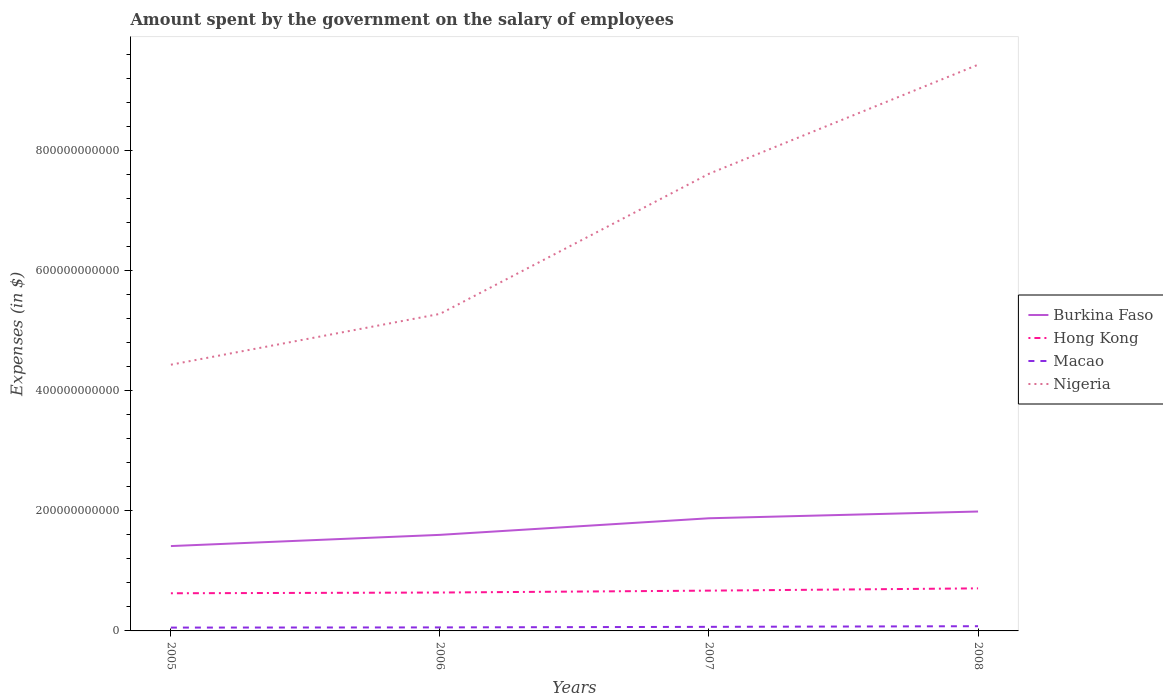How many different coloured lines are there?
Offer a very short reply. 4. Is the number of lines equal to the number of legend labels?
Your response must be concise. Yes. Across all years, what is the maximum amount spent on the salary of employees by the government in Hong Kong?
Your answer should be very brief. 6.27e+1. What is the total amount spent on the salary of employees by the government in Burkina Faso in the graph?
Make the answer very short. -3.89e+1. What is the difference between the highest and the second highest amount spent on the salary of employees by the government in Macao?
Your answer should be very brief. 2.30e+09. Is the amount spent on the salary of employees by the government in Hong Kong strictly greater than the amount spent on the salary of employees by the government in Nigeria over the years?
Provide a succinct answer. Yes. What is the difference between two consecutive major ticks on the Y-axis?
Offer a very short reply. 2.00e+11. Does the graph contain any zero values?
Offer a terse response. No. What is the title of the graph?
Keep it short and to the point. Amount spent by the government on the salary of employees. Does "Guam" appear as one of the legend labels in the graph?
Give a very brief answer. No. What is the label or title of the Y-axis?
Give a very brief answer. Expenses (in $). What is the Expenses (in $) of Burkina Faso in 2005?
Give a very brief answer. 1.41e+11. What is the Expenses (in $) in Hong Kong in 2005?
Ensure brevity in your answer.  6.27e+1. What is the Expenses (in $) in Macao in 2005?
Give a very brief answer. 5.54e+09. What is the Expenses (in $) of Nigeria in 2005?
Offer a terse response. 4.43e+11. What is the Expenses (in $) in Burkina Faso in 2006?
Offer a very short reply. 1.60e+11. What is the Expenses (in $) in Hong Kong in 2006?
Provide a short and direct response. 6.39e+1. What is the Expenses (in $) in Macao in 2006?
Your answer should be compact. 5.86e+09. What is the Expenses (in $) in Nigeria in 2006?
Provide a short and direct response. 5.28e+11. What is the Expenses (in $) in Burkina Faso in 2007?
Give a very brief answer. 1.88e+11. What is the Expenses (in $) in Hong Kong in 2007?
Offer a terse response. 6.71e+1. What is the Expenses (in $) of Macao in 2007?
Give a very brief answer. 6.79e+09. What is the Expenses (in $) in Nigeria in 2007?
Provide a succinct answer. 7.61e+11. What is the Expenses (in $) of Burkina Faso in 2008?
Give a very brief answer. 1.99e+11. What is the Expenses (in $) in Hong Kong in 2008?
Ensure brevity in your answer.  7.09e+1. What is the Expenses (in $) in Macao in 2008?
Your answer should be compact. 7.85e+09. What is the Expenses (in $) in Nigeria in 2008?
Provide a short and direct response. 9.43e+11. Across all years, what is the maximum Expenses (in $) of Burkina Faso?
Offer a terse response. 1.99e+11. Across all years, what is the maximum Expenses (in $) of Hong Kong?
Ensure brevity in your answer.  7.09e+1. Across all years, what is the maximum Expenses (in $) of Macao?
Provide a succinct answer. 7.85e+09. Across all years, what is the maximum Expenses (in $) in Nigeria?
Give a very brief answer. 9.43e+11. Across all years, what is the minimum Expenses (in $) of Burkina Faso?
Ensure brevity in your answer.  1.41e+11. Across all years, what is the minimum Expenses (in $) of Hong Kong?
Provide a short and direct response. 6.27e+1. Across all years, what is the minimum Expenses (in $) of Macao?
Give a very brief answer. 5.54e+09. Across all years, what is the minimum Expenses (in $) in Nigeria?
Offer a very short reply. 4.43e+11. What is the total Expenses (in $) of Burkina Faso in the graph?
Offer a very short reply. 6.88e+11. What is the total Expenses (in $) in Hong Kong in the graph?
Give a very brief answer. 2.65e+11. What is the total Expenses (in $) in Macao in the graph?
Provide a short and direct response. 2.60e+1. What is the total Expenses (in $) in Nigeria in the graph?
Offer a terse response. 2.68e+12. What is the difference between the Expenses (in $) of Burkina Faso in 2005 and that in 2006?
Your answer should be very brief. -1.87e+1. What is the difference between the Expenses (in $) in Hong Kong in 2005 and that in 2006?
Provide a succinct answer. -1.22e+09. What is the difference between the Expenses (in $) of Macao in 2005 and that in 2006?
Your answer should be compact. -3.16e+08. What is the difference between the Expenses (in $) in Nigeria in 2005 and that in 2006?
Provide a succinct answer. -8.46e+1. What is the difference between the Expenses (in $) in Burkina Faso in 2005 and that in 2007?
Your response must be concise. -4.63e+1. What is the difference between the Expenses (in $) of Hong Kong in 2005 and that in 2007?
Make the answer very short. -4.39e+09. What is the difference between the Expenses (in $) of Macao in 2005 and that in 2007?
Make the answer very short. -1.24e+09. What is the difference between the Expenses (in $) in Nigeria in 2005 and that in 2007?
Make the answer very short. -3.18e+11. What is the difference between the Expenses (in $) of Burkina Faso in 2005 and that in 2008?
Your answer should be compact. -5.75e+1. What is the difference between the Expenses (in $) of Hong Kong in 2005 and that in 2008?
Ensure brevity in your answer.  -8.16e+09. What is the difference between the Expenses (in $) of Macao in 2005 and that in 2008?
Ensure brevity in your answer.  -2.30e+09. What is the difference between the Expenses (in $) in Nigeria in 2005 and that in 2008?
Offer a terse response. -5.00e+11. What is the difference between the Expenses (in $) of Burkina Faso in 2006 and that in 2007?
Keep it short and to the point. -2.76e+1. What is the difference between the Expenses (in $) of Hong Kong in 2006 and that in 2007?
Your answer should be very brief. -3.17e+09. What is the difference between the Expenses (in $) in Macao in 2006 and that in 2007?
Give a very brief answer. -9.25e+08. What is the difference between the Expenses (in $) in Nigeria in 2006 and that in 2007?
Offer a very short reply. -2.33e+11. What is the difference between the Expenses (in $) of Burkina Faso in 2006 and that in 2008?
Your answer should be compact. -3.89e+1. What is the difference between the Expenses (in $) of Hong Kong in 2006 and that in 2008?
Ensure brevity in your answer.  -6.95e+09. What is the difference between the Expenses (in $) of Macao in 2006 and that in 2008?
Provide a succinct answer. -1.99e+09. What is the difference between the Expenses (in $) in Nigeria in 2006 and that in 2008?
Provide a succinct answer. -4.15e+11. What is the difference between the Expenses (in $) in Burkina Faso in 2007 and that in 2008?
Offer a very short reply. -1.12e+1. What is the difference between the Expenses (in $) of Hong Kong in 2007 and that in 2008?
Your response must be concise. -3.78e+09. What is the difference between the Expenses (in $) in Macao in 2007 and that in 2008?
Your answer should be compact. -1.06e+09. What is the difference between the Expenses (in $) in Nigeria in 2007 and that in 2008?
Offer a very short reply. -1.82e+11. What is the difference between the Expenses (in $) of Burkina Faso in 2005 and the Expenses (in $) of Hong Kong in 2006?
Your answer should be compact. 7.74e+1. What is the difference between the Expenses (in $) of Burkina Faso in 2005 and the Expenses (in $) of Macao in 2006?
Provide a short and direct response. 1.35e+11. What is the difference between the Expenses (in $) in Burkina Faso in 2005 and the Expenses (in $) in Nigeria in 2006?
Make the answer very short. -3.87e+11. What is the difference between the Expenses (in $) of Hong Kong in 2005 and the Expenses (in $) of Macao in 2006?
Ensure brevity in your answer.  5.68e+1. What is the difference between the Expenses (in $) of Hong Kong in 2005 and the Expenses (in $) of Nigeria in 2006?
Provide a succinct answer. -4.65e+11. What is the difference between the Expenses (in $) of Macao in 2005 and the Expenses (in $) of Nigeria in 2006?
Ensure brevity in your answer.  -5.22e+11. What is the difference between the Expenses (in $) in Burkina Faso in 2005 and the Expenses (in $) in Hong Kong in 2007?
Give a very brief answer. 7.42e+1. What is the difference between the Expenses (in $) in Burkina Faso in 2005 and the Expenses (in $) in Macao in 2007?
Provide a short and direct response. 1.35e+11. What is the difference between the Expenses (in $) of Burkina Faso in 2005 and the Expenses (in $) of Nigeria in 2007?
Offer a very short reply. -6.20e+11. What is the difference between the Expenses (in $) in Hong Kong in 2005 and the Expenses (in $) in Macao in 2007?
Offer a very short reply. 5.59e+1. What is the difference between the Expenses (in $) of Hong Kong in 2005 and the Expenses (in $) of Nigeria in 2007?
Your answer should be very brief. -6.98e+11. What is the difference between the Expenses (in $) in Macao in 2005 and the Expenses (in $) in Nigeria in 2007?
Ensure brevity in your answer.  -7.56e+11. What is the difference between the Expenses (in $) of Burkina Faso in 2005 and the Expenses (in $) of Hong Kong in 2008?
Keep it short and to the point. 7.04e+1. What is the difference between the Expenses (in $) of Burkina Faso in 2005 and the Expenses (in $) of Macao in 2008?
Keep it short and to the point. 1.33e+11. What is the difference between the Expenses (in $) in Burkina Faso in 2005 and the Expenses (in $) in Nigeria in 2008?
Give a very brief answer. -8.02e+11. What is the difference between the Expenses (in $) in Hong Kong in 2005 and the Expenses (in $) in Macao in 2008?
Keep it short and to the point. 5.49e+1. What is the difference between the Expenses (in $) in Hong Kong in 2005 and the Expenses (in $) in Nigeria in 2008?
Your answer should be compact. -8.80e+11. What is the difference between the Expenses (in $) in Macao in 2005 and the Expenses (in $) in Nigeria in 2008?
Give a very brief answer. -9.37e+11. What is the difference between the Expenses (in $) in Burkina Faso in 2006 and the Expenses (in $) in Hong Kong in 2007?
Your response must be concise. 9.29e+1. What is the difference between the Expenses (in $) of Burkina Faso in 2006 and the Expenses (in $) of Macao in 2007?
Your response must be concise. 1.53e+11. What is the difference between the Expenses (in $) in Burkina Faso in 2006 and the Expenses (in $) in Nigeria in 2007?
Offer a very short reply. -6.01e+11. What is the difference between the Expenses (in $) of Hong Kong in 2006 and the Expenses (in $) of Macao in 2007?
Your answer should be compact. 5.71e+1. What is the difference between the Expenses (in $) in Hong Kong in 2006 and the Expenses (in $) in Nigeria in 2007?
Your answer should be compact. -6.97e+11. What is the difference between the Expenses (in $) in Macao in 2006 and the Expenses (in $) in Nigeria in 2007?
Your answer should be very brief. -7.55e+11. What is the difference between the Expenses (in $) of Burkina Faso in 2006 and the Expenses (in $) of Hong Kong in 2008?
Keep it short and to the point. 8.91e+1. What is the difference between the Expenses (in $) in Burkina Faso in 2006 and the Expenses (in $) in Macao in 2008?
Offer a terse response. 1.52e+11. What is the difference between the Expenses (in $) in Burkina Faso in 2006 and the Expenses (in $) in Nigeria in 2008?
Your answer should be compact. -7.83e+11. What is the difference between the Expenses (in $) in Hong Kong in 2006 and the Expenses (in $) in Macao in 2008?
Offer a very short reply. 5.61e+1. What is the difference between the Expenses (in $) of Hong Kong in 2006 and the Expenses (in $) of Nigeria in 2008?
Provide a short and direct response. -8.79e+11. What is the difference between the Expenses (in $) of Macao in 2006 and the Expenses (in $) of Nigeria in 2008?
Your answer should be compact. -9.37e+11. What is the difference between the Expenses (in $) in Burkina Faso in 2007 and the Expenses (in $) in Hong Kong in 2008?
Your answer should be very brief. 1.17e+11. What is the difference between the Expenses (in $) in Burkina Faso in 2007 and the Expenses (in $) in Macao in 2008?
Provide a short and direct response. 1.80e+11. What is the difference between the Expenses (in $) in Burkina Faso in 2007 and the Expenses (in $) in Nigeria in 2008?
Offer a very short reply. -7.55e+11. What is the difference between the Expenses (in $) of Hong Kong in 2007 and the Expenses (in $) of Macao in 2008?
Offer a very short reply. 5.92e+1. What is the difference between the Expenses (in $) of Hong Kong in 2007 and the Expenses (in $) of Nigeria in 2008?
Your answer should be compact. -8.76e+11. What is the difference between the Expenses (in $) of Macao in 2007 and the Expenses (in $) of Nigeria in 2008?
Keep it short and to the point. -9.36e+11. What is the average Expenses (in $) in Burkina Faso per year?
Provide a short and direct response. 1.72e+11. What is the average Expenses (in $) of Hong Kong per year?
Offer a very short reply. 6.61e+1. What is the average Expenses (in $) in Macao per year?
Offer a very short reply. 6.51e+09. What is the average Expenses (in $) in Nigeria per year?
Offer a terse response. 6.69e+11. In the year 2005, what is the difference between the Expenses (in $) of Burkina Faso and Expenses (in $) of Hong Kong?
Keep it short and to the point. 7.86e+1. In the year 2005, what is the difference between the Expenses (in $) in Burkina Faso and Expenses (in $) in Macao?
Provide a short and direct response. 1.36e+11. In the year 2005, what is the difference between the Expenses (in $) of Burkina Faso and Expenses (in $) of Nigeria?
Your response must be concise. -3.02e+11. In the year 2005, what is the difference between the Expenses (in $) in Hong Kong and Expenses (in $) in Macao?
Your response must be concise. 5.72e+1. In the year 2005, what is the difference between the Expenses (in $) of Hong Kong and Expenses (in $) of Nigeria?
Offer a very short reply. -3.81e+11. In the year 2005, what is the difference between the Expenses (in $) in Macao and Expenses (in $) in Nigeria?
Offer a terse response. -4.38e+11. In the year 2006, what is the difference between the Expenses (in $) in Burkina Faso and Expenses (in $) in Hong Kong?
Ensure brevity in your answer.  9.60e+1. In the year 2006, what is the difference between the Expenses (in $) of Burkina Faso and Expenses (in $) of Macao?
Your answer should be compact. 1.54e+11. In the year 2006, what is the difference between the Expenses (in $) of Burkina Faso and Expenses (in $) of Nigeria?
Make the answer very short. -3.68e+11. In the year 2006, what is the difference between the Expenses (in $) in Hong Kong and Expenses (in $) in Macao?
Your answer should be compact. 5.81e+1. In the year 2006, what is the difference between the Expenses (in $) of Hong Kong and Expenses (in $) of Nigeria?
Your response must be concise. -4.64e+11. In the year 2006, what is the difference between the Expenses (in $) in Macao and Expenses (in $) in Nigeria?
Keep it short and to the point. -5.22e+11. In the year 2007, what is the difference between the Expenses (in $) in Burkina Faso and Expenses (in $) in Hong Kong?
Provide a succinct answer. 1.21e+11. In the year 2007, what is the difference between the Expenses (in $) of Burkina Faso and Expenses (in $) of Macao?
Your answer should be compact. 1.81e+11. In the year 2007, what is the difference between the Expenses (in $) of Burkina Faso and Expenses (in $) of Nigeria?
Offer a terse response. -5.74e+11. In the year 2007, what is the difference between the Expenses (in $) of Hong Kong and Expenses (in $) of Macao?
Give a very brief answer. 6.03e+1. In the year 2007, what is the difference between the Expenses (in $) in Hong Kong and Expenses (in $) in Nigeria?
Make the answer very short. -6.94e+11. In the year 2007, what is the difference between the Expenses (in $) in Macao and Expenses (in $) in Nigeria?
Provide a succinct answer. -7.54e+11. In the year 2008, what is the difference between the Expenses (in $) of Burkina Faso and Expenses (in $) of Hong Kong?
Provide a succinct answer. 1.28e+11. In the year 2008, what is the difference between the Expenses (in $) in Burkina Faso and Expenses (in $) in Macao?
Give a very brief answer. 1.91e+11. In the year 2008, what is the difference between the Expenses (in $) of Burkina Faso and Expenses (in $) of Nigeria?
Your answer should be very brief. -7.44e+11. In the year 2008, what is the difference between the Expenses (in $) of Hong Kong and Expenses (in $) of Macao?
Offer a very short reply. 6.30e+1. In the year 2008, what is the difference between the Expenses (in $) of Hong Kong and Expenses (in $) of Nigeria?
Offer a terse response. -8.72e+11. In the year 2008, what is the difference between the Expenses (in $) of Macao and Expenses (in $) of Nigeria?
Your answer should be compact. -9.35e+11. What is the ratio of the Expenses (in $) in Burkina Faso in 2005 to that in 2006?
Provide a short and direct response. 0.88. What is the ratio of the Expenses (in $) of Hong Kong in 2005 to that in 2006?
Make the answer very short. 0.98. What is the ratio of the Expenses (in $) in Macao in 2005 to that in 2006?
Your answer should be very brief. 0.95. What is the ratio of the Expenses (in $) in Nigeria in 2005 to that in 2006?
Your response must be concise. 0.84. What is the ratio of the Expenses (in $) of Burkina Faso in 2005 to that in 2007?
Offer a very short reply. 0.75. What is the ratio of the Expenses (in $) in Hong Kong in 2005 to that in 2007?
Offer a very short reply. 0.93. What is the ratio of the Expenses (in $) of Macao in 2005 to that in 2007?
Your answer should be very brief. 0.82. What is the ratio of the Expenses (in $) in Nigeria in 2005 to that in 2007?
Make the answer very short. 0.58. What is the ratio of the Expenses (in $) in Burkina Faso in 2005 to that in 2008?
Ensure brevity in your answer.  0.71. What is the ratio of the Expenses (in $) in Hong Kong in 2005 to that in 2008?
Keep it short and to the point. 0.88. What is the ratio of the Expenses (in $) of Macao in 2005 to that in 2008?
Give a very brief answer. 0.71. What is the ratio of the Expenses (in $) in Nigeria in 2005 to that in 2008?
Make the answer very short. 0.47. What is the ratio of the Expenses (in $) of Burkina Faso in 2006 to that in 2007?
Your answer should be compact. 0.85. What is the ratio of the Expenses (in $) in Hong Kong in 2006 to that in 2007?
Give a very brief answer. 0.95. What is the ratio of the Expenses (in $) of Macao in 2006 to that in 2007?
Your response must be concise. 0.86. What is the ratio of the Expenses (in $) of Nigeria in 2006 to that in 2007?
Make the answer very short. 0.69. What is the ratio of the Expenses (in $) in Burkina Faso in 2006 to that in 2008?
Your answer should be compact. 0.8. What is the ratio of the Expenses (in $) of Hong Kong in 2006 to that in 2008?
Provide a short and direct response. 0.9. What is the ratio of the Expenses (in $) of Macao in 2006 to that in 2008?
Provide a short and direct response. 0.75. What is the ratio of the Expenses (in $) in Nigeria in 2006 to that in 2008?
Give a very brief answer. 0.56. What is the ratio of the Expenses (in $) of Burkina Faso in 2007 to that in 2008?
Make the answer very short. 0.94. What is the ratio of the Expenses (in $) in Hong Kong in 2007 to that in 2008?
Ensure brevity in your answer.  0.95. What is the ratio of the Expenses (in $) of Macao in 2007 to that in 2008?
Offer a terse response. 0.86. What is the ratio of the Expenses (in $) in Nigeria in 2007 to that in 2008?
Give a very brief answer. 0.81. What is the difference between the highest and the second highest Expenses (in $) in Burkina Faso?
Ensure brevity in your answer.  1.12e+1. What is the difference between the highest and the second highest Expenses (in $) of Hong Kong?
Give a very brief answer. 3.78e+09. What is the difference between the highest and the second highest Expenses (in $) of Macao?
Make the answer very short. 1.06e+09. What is the difference between the highest and the second highest Expenses (in $) in Nigeria?
Your response must be concise. 1.82e+11. What is the difference between the highest and the lowest Expenses (in $) in Burkina Faso?
Keep it short and to the point. 5.75e+1. What is the difference between the highest and the lowest Expenses (in $) of Hong Kong?
Provide a short and direct response. 8.16e+09. What is the difference between the highest and the lowest Expenses (in $) in Macao?
Make the answer very short. 2.30e+09. What is the difference between the highest and the lowest Expenses (in $) of Nigeria?
Ensure brevity in your answer.  5.00e+11. 